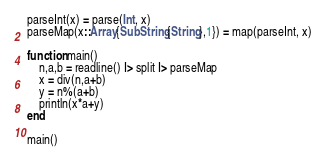Convert code to text. <code><loc_0><loc_0><loc_500><loc_500><_Julia_>parseInt(x) = parse(Int, x)
parseMap(x::Array{SubString{String},1}) = map(parseInt, x)

function main()
	n,a,b = readline() |> split |> parseMap
	x = div(n,a+b)
	y = n%(a+b)
	println(x*a+y)
end

main()</code> 